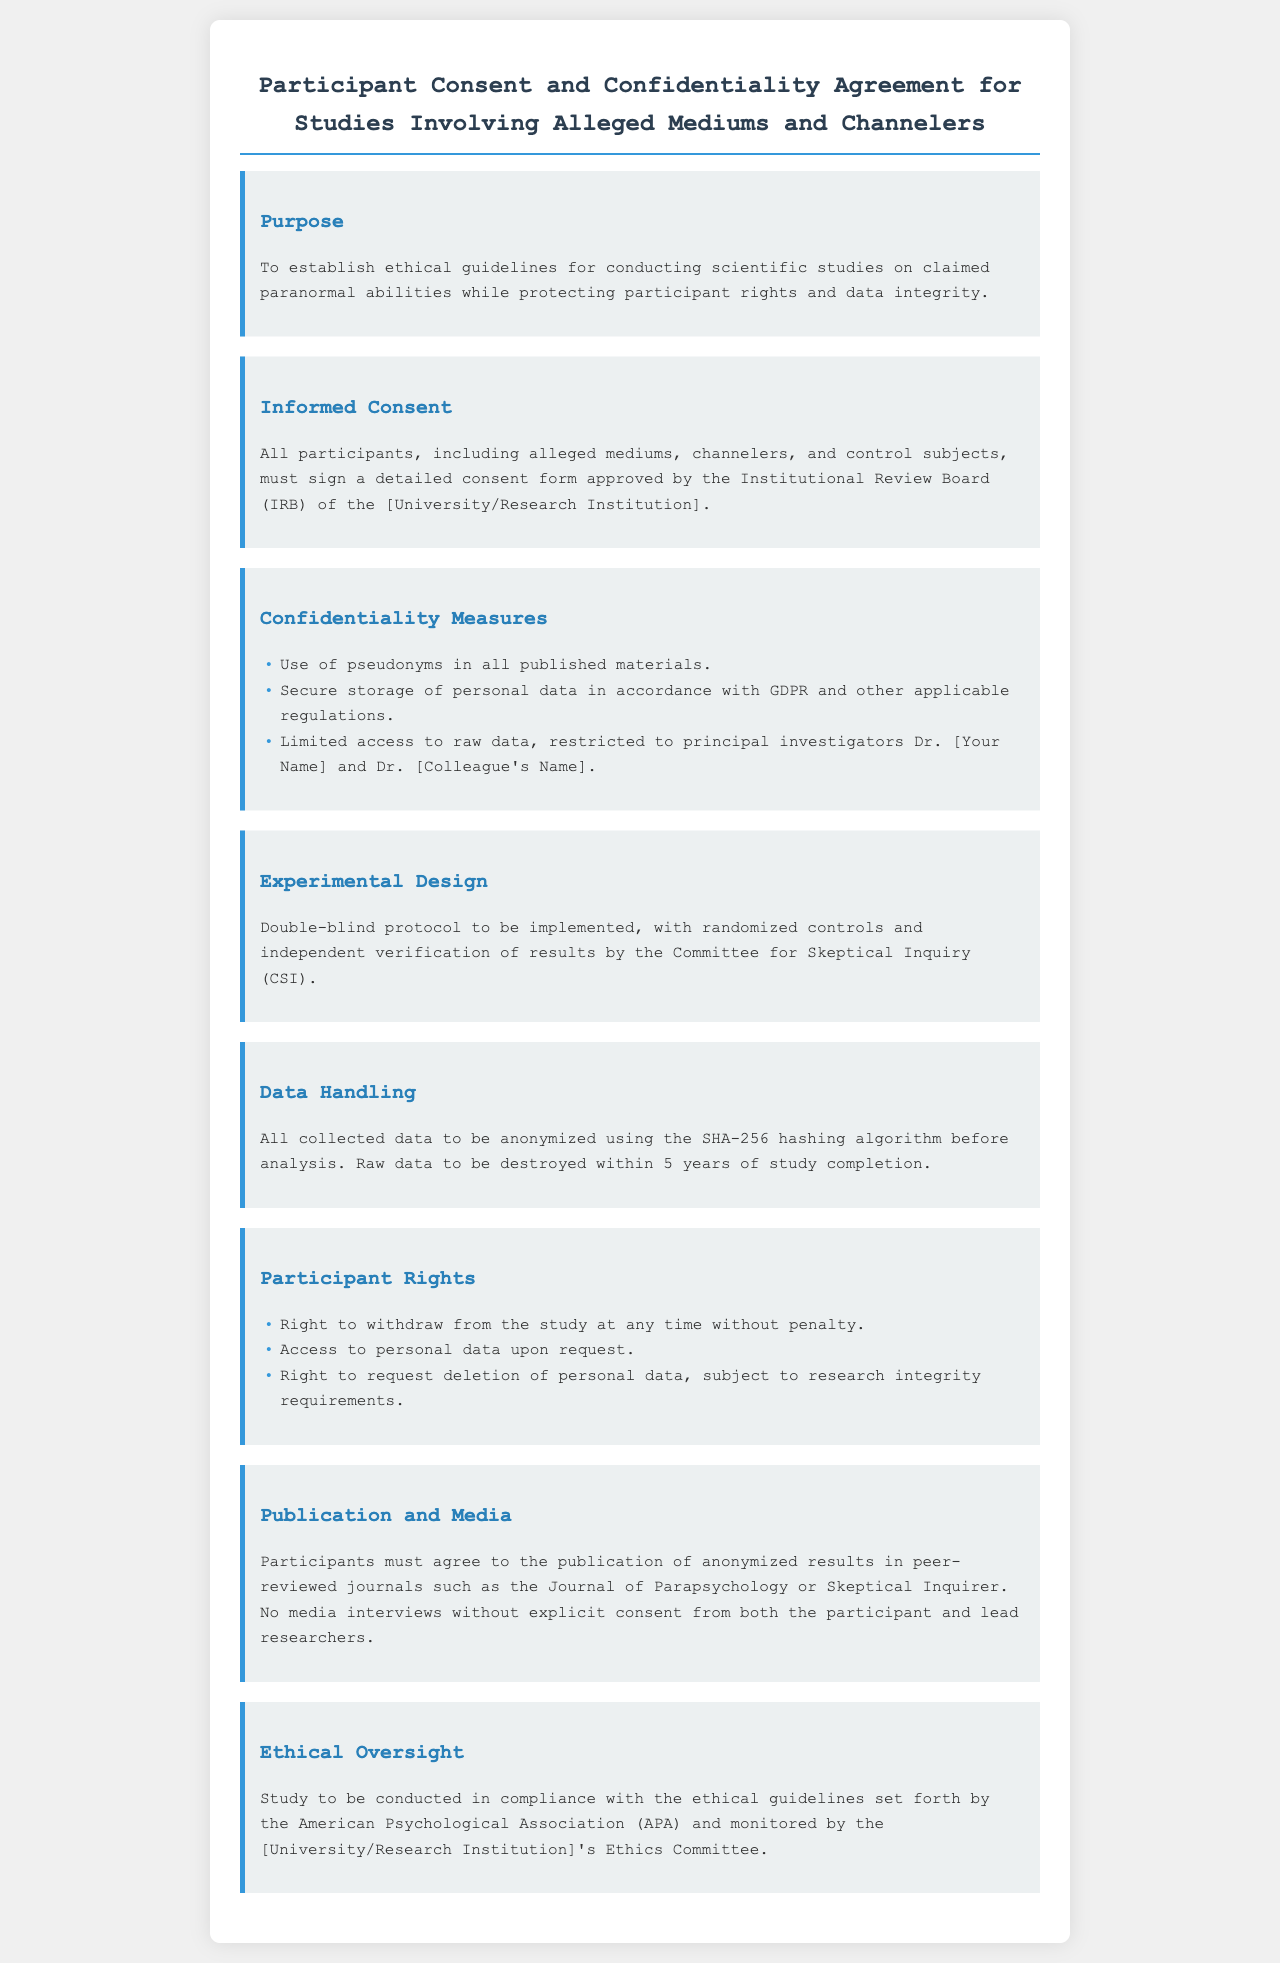What is the purpose of the document? The purpose is outlined in the section titled "Purpose," which states it establishes ethical guidelines for conducting studies while protecting participant rights and data integrity.
Answer: Establish ethical guidelines What must participants sign? The section titled "Informed Consent" specifies that participants must sign a detailed consent form.
Answer: Detailed consent form Who has access to raw data? The "Confidentiality Measures" section specifies that access to raw data is restricted to the principal investigators, Dr. [Your Name] and Dr. [Colleague's Name].
Answer: Principal investigators How long will raw data be stored? The "Data Handling" section indicates that raw data will be destroyed within 5 years of study completion.
Answer: 5 years What type of protocol will be implemented? The "Experimental Design" section mentions that a double-blind protocol will be implemented.
Answer: Double-blind protocol What right do participants have regarding their data? The "Participant Rights" section states that participants have the right to access their personal data upon request.
Answer: Access to personal data Which ethical guidelines must the study comply with? The "Ethical Oversight" section states that the study must comply with ethical guidelines set forth by the American Psychological Association (APA).
Answer: American Psychological Association (APA) What kind of results can be published? The "Publication and Media" section specifies that anonymized results in peer-reviewed journals can be published.
Answer: Anonymized results 